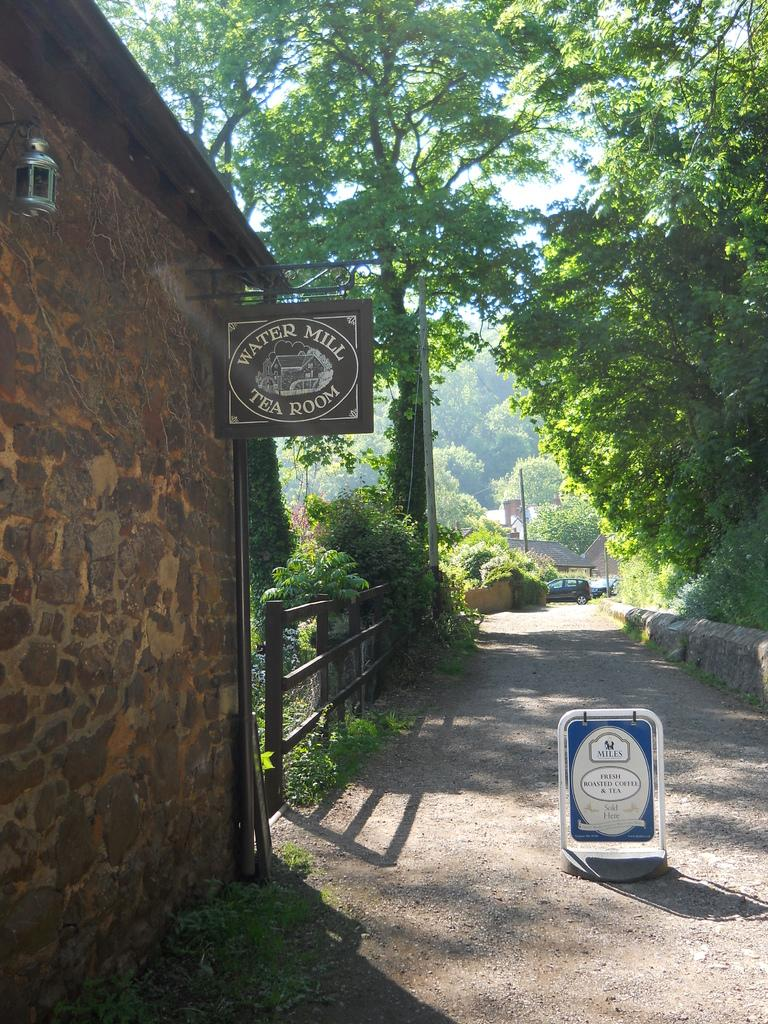What type of structures can be seen in the image? There are boards, poles, buildings, and a fence visible in the image. What type of vegetation is present in the image? There is grass, creepers, and trees in the image. What is moving along the road in the image? There are vehicles on the road in the image. What part of the natural environment is visible in the image? The sky is visible in the image. Can you describe the setting where the image might have been taken? The image may have been taken near a park, given the presence of trees and grass. What direction is the government moving in the image? There is no reference to a government or any directional movement in the image. What type of tail can be seen on the creepers in the image? There are no tails present in the image, as creepers are a type of plant and do not have tails. 